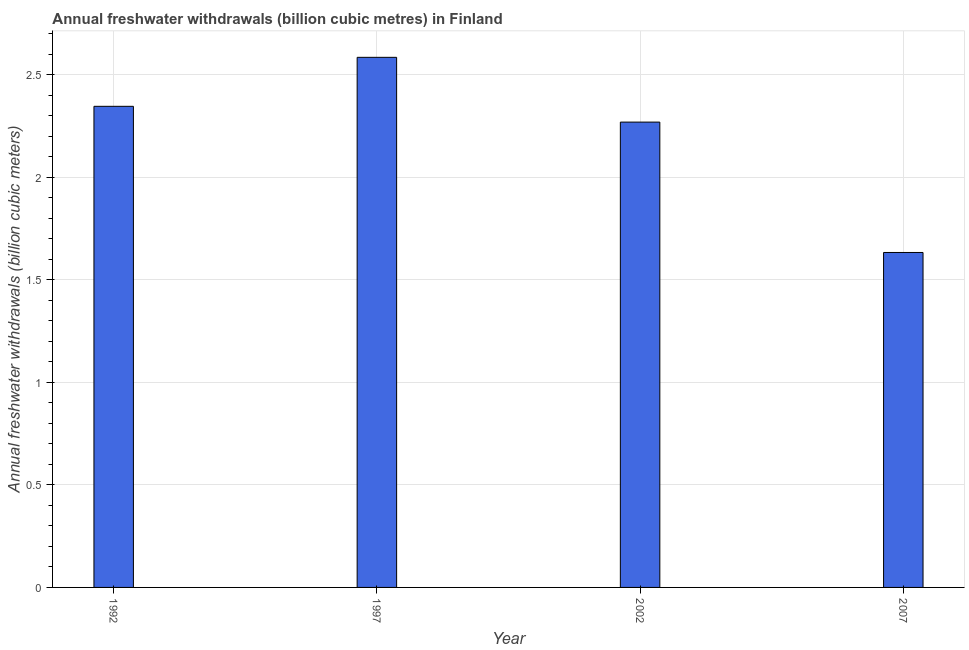What is the title of the graph?
Provide a short and direct response. Annual freshwater withdrawals (billion cubic metres) in Finland. What is the label or title of the Y-axis?
Make the answer very short. Annual freshwater withdrawals (billion cubic meters). What is the annual freshwater withdrawals in 1992?
Provide a succinct answer. 2.35. Across all years, what is the maximum annual freshwater withdrawals?
Provide a short and direct response. 2.59. Across all years, what is the minimum annual freshwater withdrawals?
Your answer should be very brief. 1.63. In which year was the annual freshwater withdrawals minimum?
Offer a terse response. 2007. What is the sum of the annual freshwater withdrawals?
Your answer should be compact. 8.84. What is the difference between the annual freshwater withdrawals in 1997 and 2002?
Your answer should be very brief. 0.32. What is the average annual freshwater withdrawals per year?
Your answer should be compact. 2.21. What is the median annual freshwater withdrawals?
Keep it short and to the point. 2.31. What is the ratio of the annual freshwater withdrawals in 1992 to that in 1997?
Provide a short and direct response. 0.91. Is the annual freshwater withdrawals in 1992 less than that in 1997?
Your answer should be compact. Yes. What is the difference between the highest and the second highest annual freshwater withdrawals?
Provide a short and direct response. 0.24. What is the difference between the highest and the lowest annual freshwater withdrawals?
Offer a very short reply. 0.95. In how many years, is the annual freshwater withdrawals greater than the average annual freshwater withdrawals taken over all years?
Your answer should be very brief. 3. How many bars are there?
Give a very brief answer. 4. What is the difference between two consecutive major ticks on the Y-axis?
Give a very brief answer. 0.5. What is the Annual freshwater withdrawals (billion cubic meters) in 1992?
Keep it short and to the point. 2.35. What is the Annual freshwater withdrawals (billion cubic meters) in 1997?
Your response must be concise. 2.59. What is the Annual freshwater withdrawals (billion cubic meters) in 2002?
Provide a short and direct response. 2.27. What is the Annual freshwater withdrawals (billion cubic meters) of 2007?
Give a very brief answer. 1.63. What is the difference between the Annual freshwater withdrawals (billion cubic meters) in 1992 and 1997?
Make the answer very short. -0.24. What is the difference between the Annual freshwater withdrawals (billion cubic meters) in 1992 and 2002?
Provide a short and direct response. 0.08. What is the difference between the Annual freshwater withdrawals (billion cubic meters) in 1992 and 2007?
Make the answer very short. 0.71. What is the difference between the Annual freshwater withdrawals (billion cubic meters) in 1997 and 2002?
Give a very brief answer. 0.32. What is the difference between the Annual freshwater withdrawals (billion cubic meters) in 1997 and 2007?
Provide a short and direct response. 0.95. What is the difference between the Annual freshwater withdrawals (billion cubic meters) in 2002 and 2007?
Provide a succinct answer. 0.64. What is the ratio of the Annual freshwater withdrawals (billion cubic meters) in 1992 to that in 1997?
Your answer should be compact. 0.91. What is the ratio of the Annual freshwater withdrawals (billion cubic meters) in 1992 to that in 2002?
Provide a succinct answer. 1.03. What is the ratio of the Annual freshwater withdrawals (billion cubic meters) in 1992 to that in 2007?
Provide a short and direct response. 1.44. What is the ratio of the Annual freshwater withdrawals (billion cubic meters) in 1997 to that in 2002?
Ensure brevity in your answer.  1.14. What is the ratio of the Annual freshwater withdrawals (billion cubic meters) in 1997 to that in 2007?
Provide a succinct answer. 1.58. What is the ratio of the Annual freshwater withdrawals (billion cubic meters) in 2002 to that in 2007?
Keep it short and to the point. 1.39. 